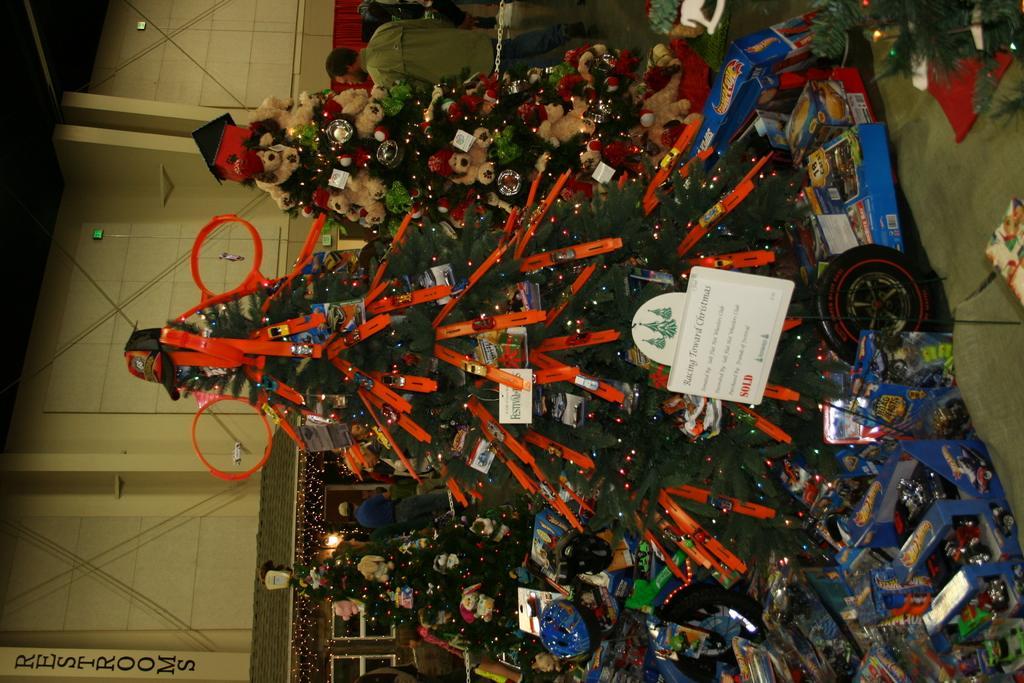Please provide a concise description of this image. We can see Christmas trees with decorative items, board with stand, cards and toys in boxes. In the background we can see people, chain, wall, wires, lights and windows. 